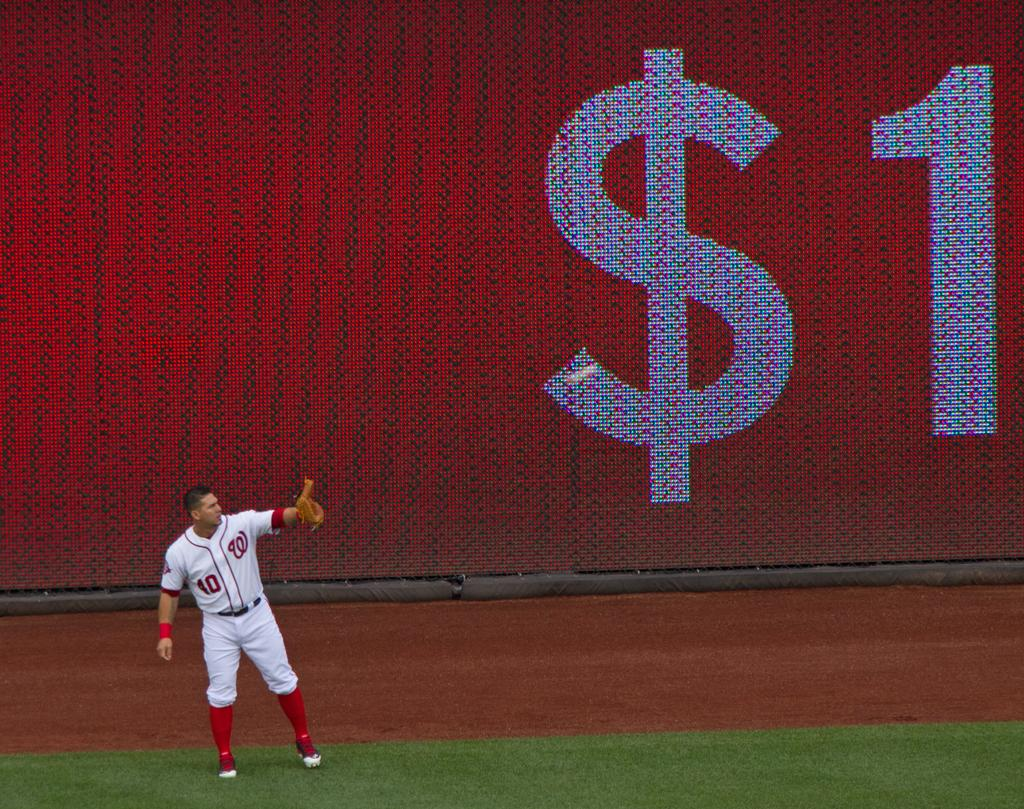<image>
Relay a brief, clear account of the picture shown. Number 40 baseball catcher with the Washington Nationals team lifting up his mitt to catch a ball. 